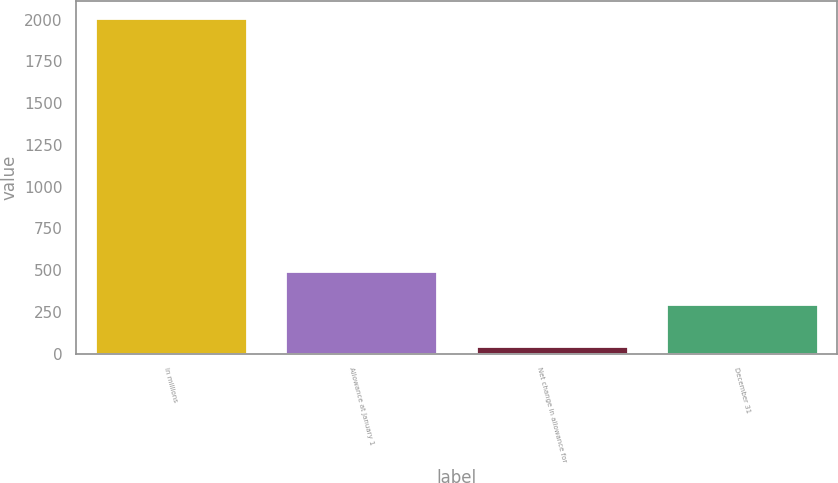<chart> <loc_0><loc_0><loc_500><loc_500><bar_chart><fcel>In millions<fcel>Allowance at January 1<fcel>Net change in allowance for<fcel>December 31<nl><fcel>2009<fcel>492.1<fcel>48<fcel>296<nl></chart> 